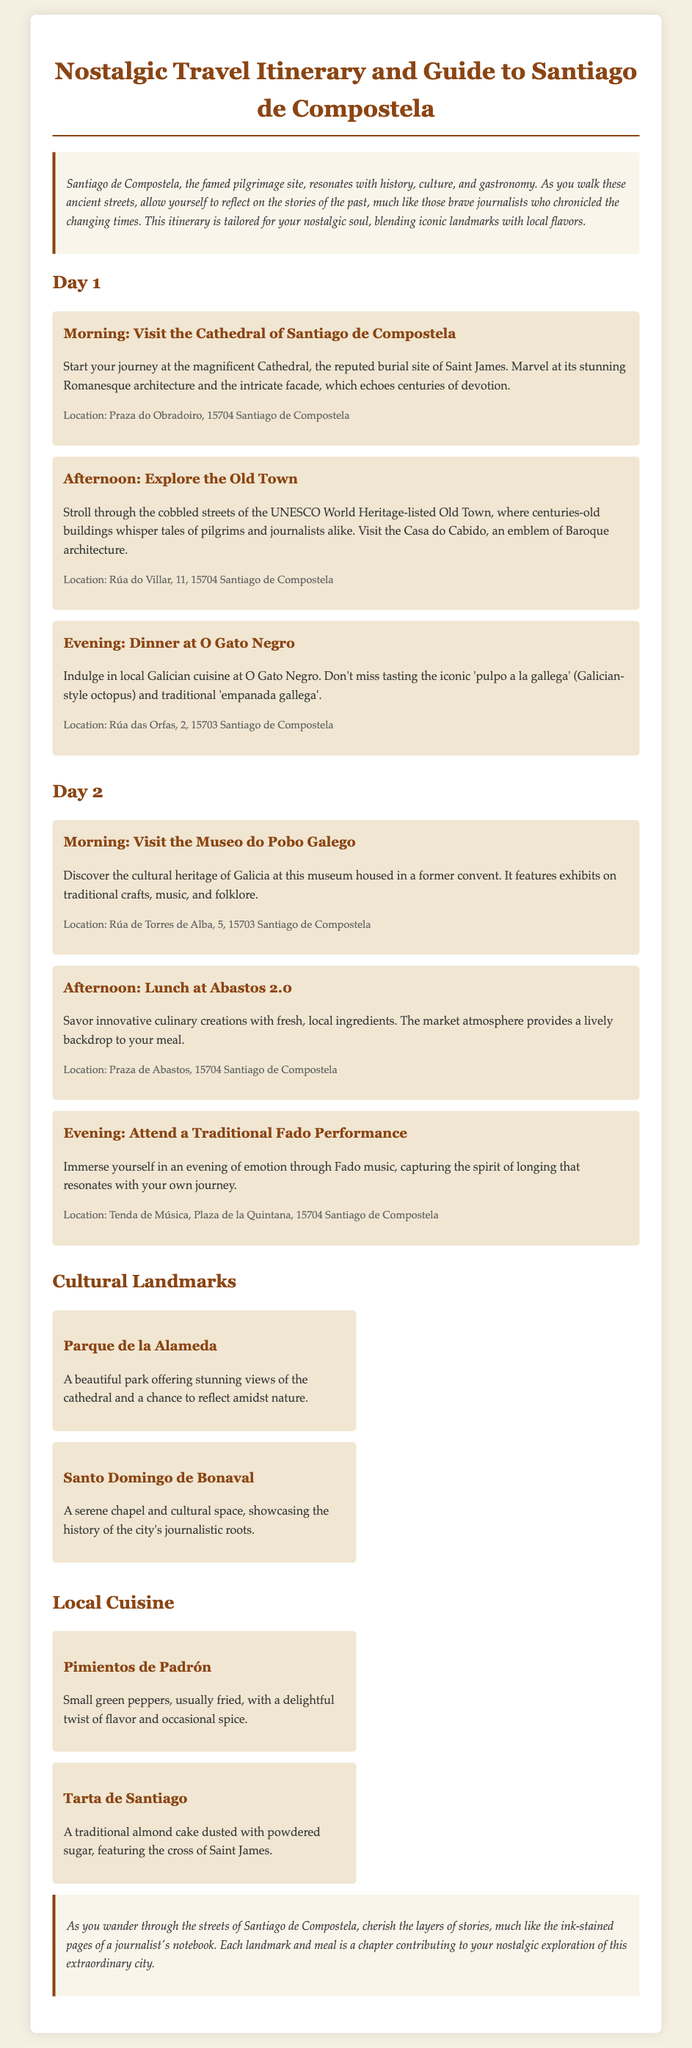What is the title of the document? The title is found in the header of the document.
Answer: Nostalgic Travel Itinerary and Guide to Santiago de Compostela What is the location of the Cathedral of Santiago de Compostela? The location details are provided in the individual activities.
Answer: Praza do Obradoiro, 15704 Santiago de Compostela What dish is recommended for dinner on Day 1? The recommended dish is mentioned in the dinner activity for Day 1.
Answer: Pulpo a la gallega What is the cultural heritage museum in Santiago de Compostela? This is mentioned as the morning activity of Day 2.
Answer: Museo do Pobo Galego How many days does the itinerary cover? The number of days is stated clearly in the document's sections.
Answer: 2 What type of music performance is suggested for the evening of Day 2? The type of performance is mentioned in the evening activity of Day 2.
Answer: Fado What is the traditional cake mentioned in the local cuisine section? The cake is listed along with its description in the local cuisine area.
Answer: Tarta de Santiago What park offers views of the cathedral? The park is identified in the cultural landmarks section.
Answer: Parque de la Alameda What is the format of the itinerary? This refers to the structure and layout described in the document.
Answer: Day-wise activities 